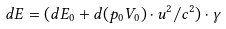<formula> <loc_0><loc_0><loc_500><loc_500>d E = ( d E _ { 0 } + d ( p _ { 0 } V _ { 0 } ) \cdot u ^ { 2 } / c ^ { 2 } ) \cdot \gamma</formula> 